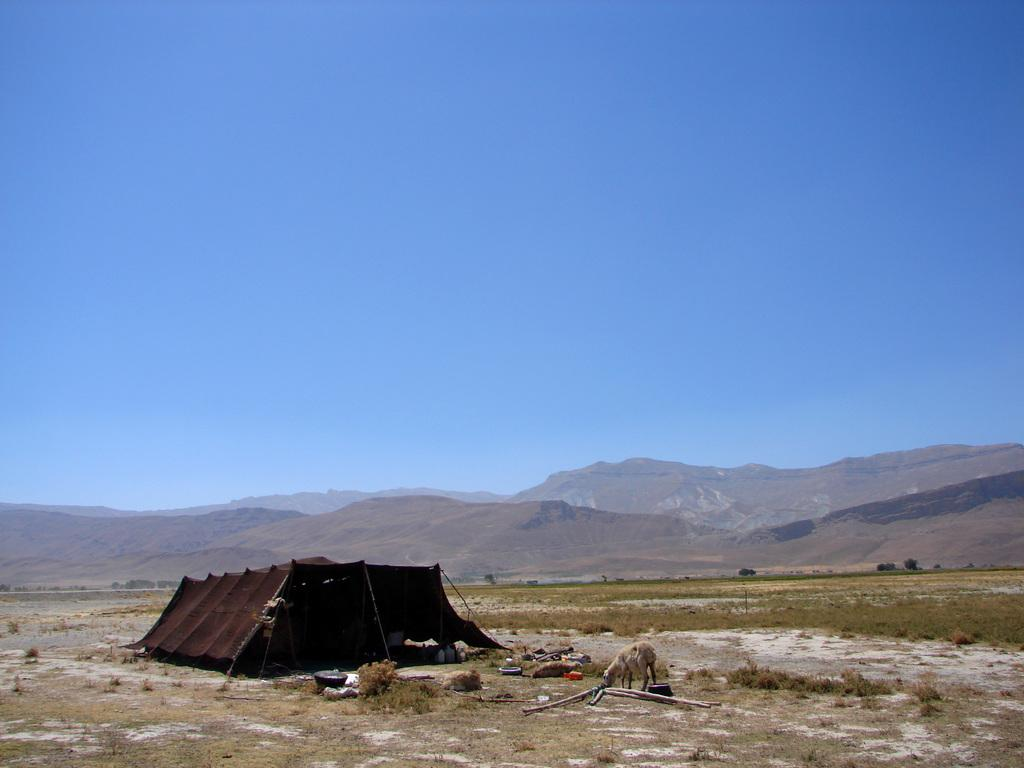What structure is present on the ground in the image? There is a tent on the ground in the image. What animal can be seen standing in the image? There is a sheep standing in the image. What type of natural formation is visible in the background of the image? There are mountains visible in the background of the image. What type of pain is the sheep experiencing in the image? There is no indication of pain or discomfort for the sheep in the image. Can you describe the toad that is sitting on the tent in the image? There is no toad present in the image; only a sheep and a tent are visible. 